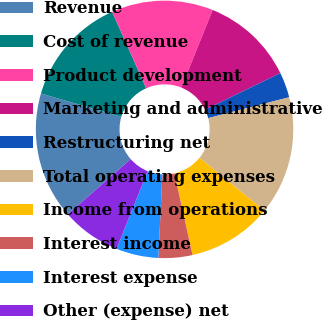Convert chart to OTSL. <chart><loc_0><loc_0><loc_500><loc_500><pie_chart><fcel>Revenue<fcel>Cost of revenue<fcel>Product development<fcel>Marketing and administrative<fcel>Restructuring net<fcel>Total operating expenses<fcel>Income from operations<fcel>Interest income<fcel>Interest expense<fcel>Other (expense) net<nl><fcel>15.96%<fcel>13.83%<fcel>12.77%<fcel>11.7%<fcel>3.19%<fcel>14.89%<fcel>10.64%<fcel>4.26%<fcel>5.32%<fcel>7.45%<nl></chart> 